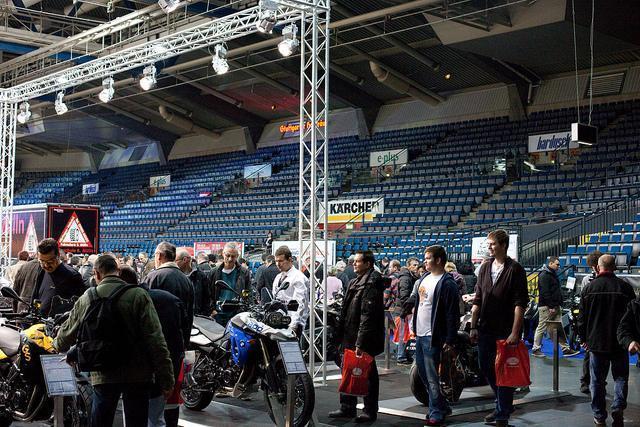What type of vehicle are the people looking at?
Answer the question by selecting the correct answer among the 4 following choices.
Options: Car, boat, plane, motorcycle. Motorcycle. 